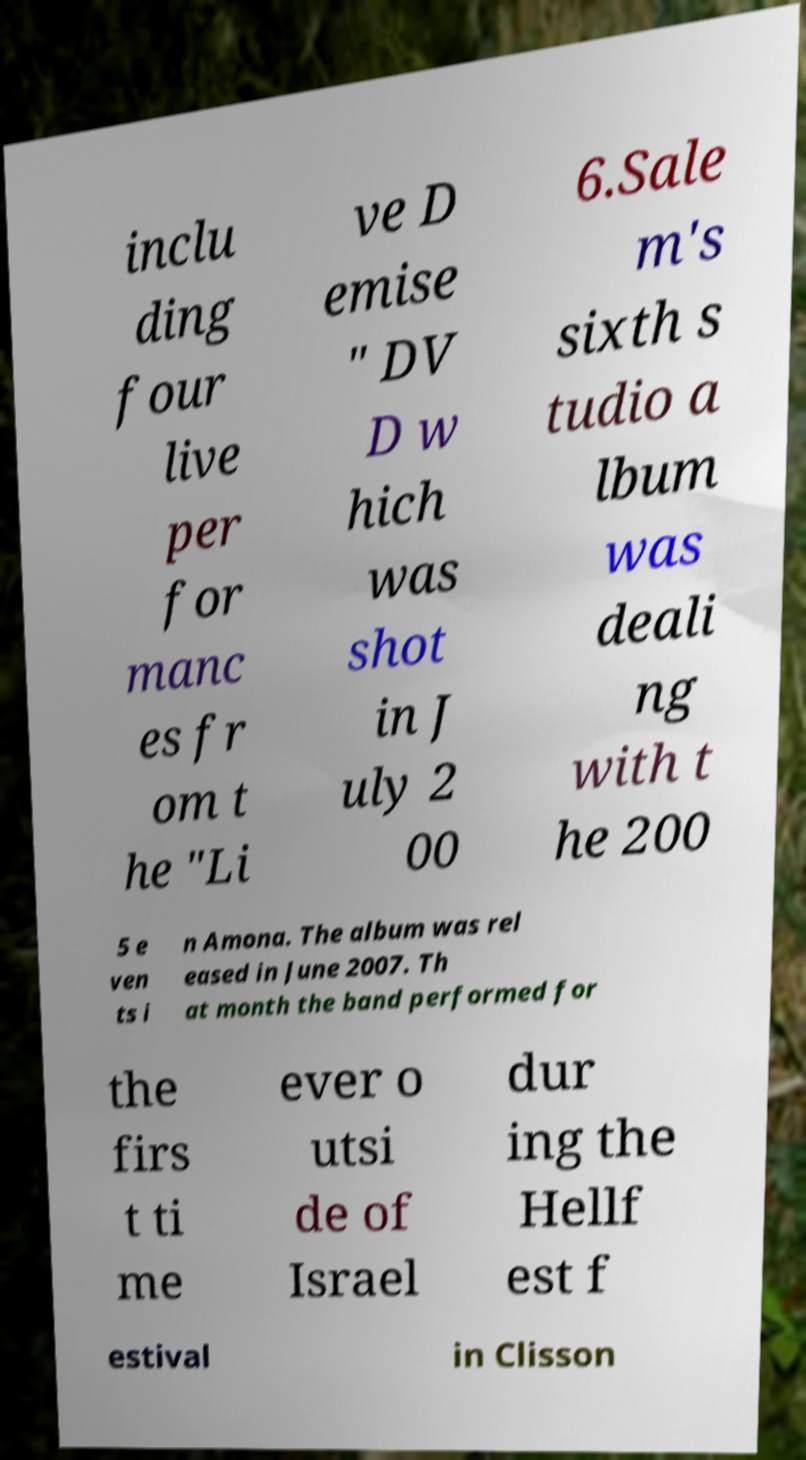Can you accurately transcribe the text from the provided image for me? inclu ding four live per for manc es fr om t he "Li ve D emise " DV D w hich was shot in J uly 2 00 6.Sale m's sixth s tudio a lbum was deali ng with t he 200 5 e ven ts i n Amona. The album was rel eased in June 2007. Th at month the band performed for the firs t ti me ever o utsi de of Israel dur ing the Hellf est f estival in Clisson 